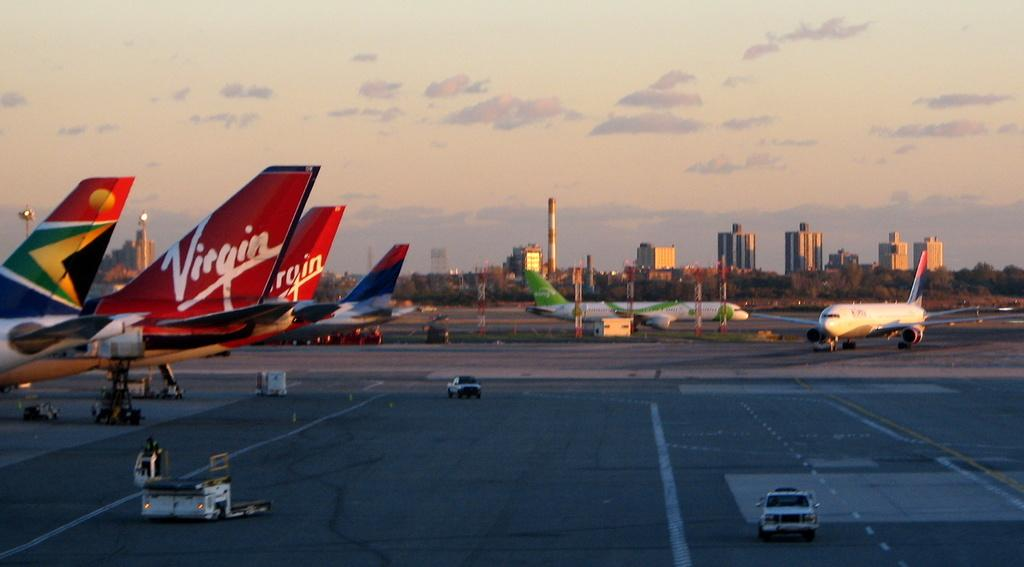<image>
Write a terse but informative summary of the picture. Several planes for Virgin airlines line up on the pavement. 